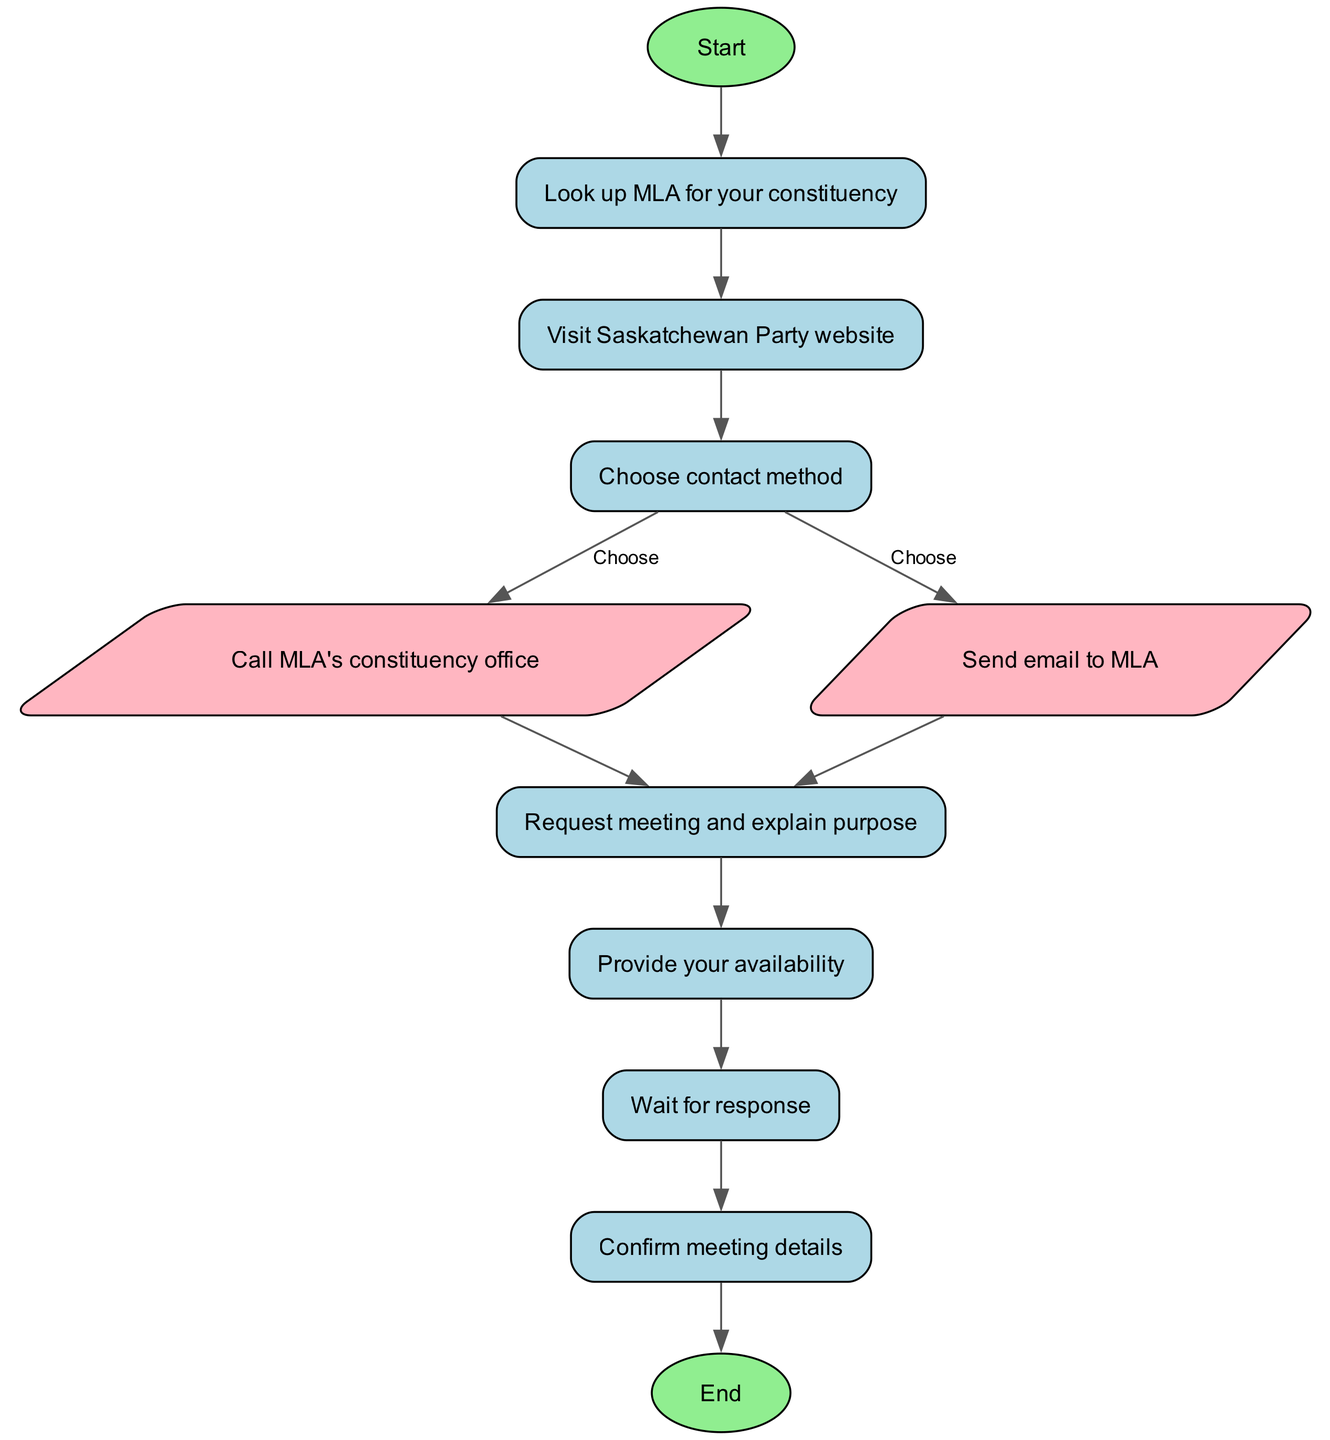What is the first step in the procedure? The first step in the flow chart is labeled "Start," indicating that this is where the procedure begins.
Answer: Start How many contact methods are available? The flow chart shows two pathways stemming from the "Choose contact method" node: "Call MLA's constituency office" and "Send email to MLA." Therefore, there are two methods available.
Answer: Two What do you do after requesting a meeting? After requesting a meeting, the next action is to "Provide your availability," according to the flow of the diagram following the "Request meeting and explain purpose."
Answer: Provide your availability What shape represents the end of the process? The "End" node is represented as an ellipse, which is the designated shape for both the starting and ending points in this flow chart.
Answer: Ellipse What decision must you make after checking the website? After checking the website, you must "Choose contact method," which indicates a decision point in the process before proceeding to contact the MLA.
Answer: Choose contact method How does one proceed after waiting for a response? Once the waiting period is over, the subsequent step is to "Confirm meeting details," reflecting the logical sequence after awaiting communication.
Answer: Confirm meeting details What is the connection between 'email' and 'request meeting'? The connection indicates that after selecting the option to "Send email to MLA," the next step is to "Request meeting and explain purpose," establishing a direct flow from one action to the next.
Answer: Request meeting Which node is a parallelogram in the diagram? The "Call MLA's constituency office" and "Send email to MLA" nodes are shaped as parallelograms, indicating they are contact methods in the process.
Answer: Call MLA's constituency office, Send email to MLA What indicates the point at which to conclude the process? The diagram concludes at the "End" node, which signifies the completion of the entire procedure for contacting and scheduling a meeting with a local MLA.
Answer: End 